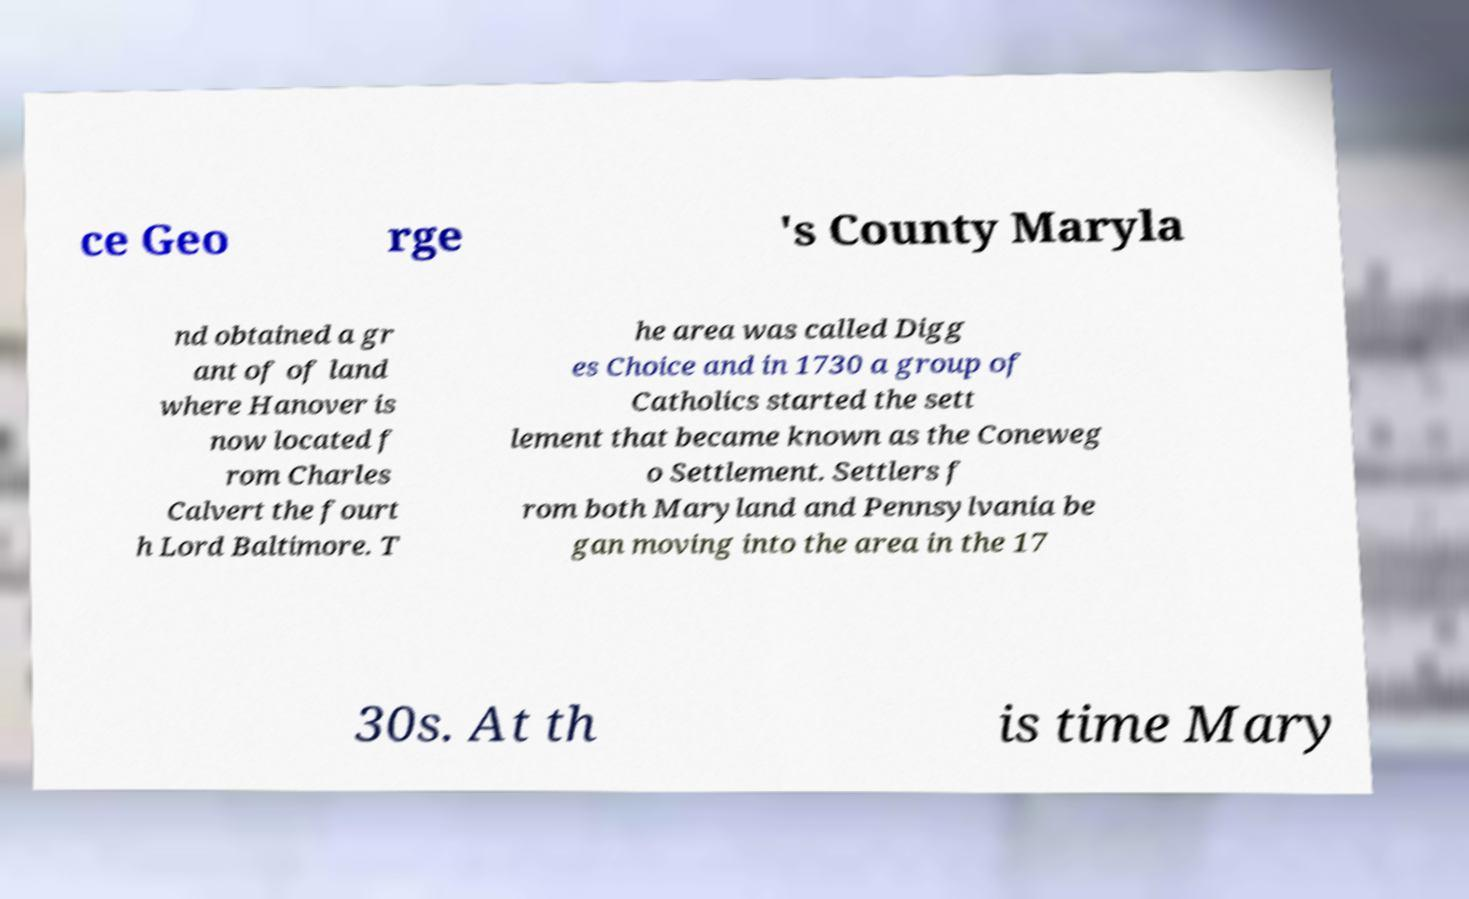There's text embedded in this image that I need extracted. Can you transcribe it verbatim? ce Geo rge 's County Maryla nd obtained a gr ant of of land where Hanover is now located f rom Charles Calvert the fourt h Lord Baltimore. T he area was called Digg es Choice and in 1730 a group of Catholics started the sett lement that became known as the Coneweg o Settlement. Settlers f rom both Maryland and Pennsylvania be gan moving into the area in the 17 30s. At th is time Mary 